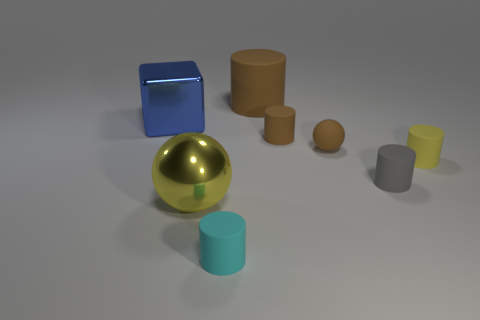Are there any gray things of the same size as the cyan matte cylinder?
Your answer should be compact. Yes. There is a blue thing left of the cyan cylinder; does it have the same shape as the gray object?
Keep it short and to the point. No. Does the tiny yellow rubber thing have the same shape as the blue shiny object?
Give a very brief answer. No. Is there another big green object of the same shape as the large rubber object?
Make the answer very short. No. There is a big object on the right side of the small cylinder in front of the large yellow object; what shape is it?
Offer a very short reply. Cylinder. The matte thing that is behind the large shiny cube is what color?
Ensure brevity in your answer.  Brown. What is the size of the cyan cylinder that is the same material as the tiny gray object?
Provide a succinct answer. Small. There is a gray rubber thing that is the same shape as the yellow rubber thing; what is its size?
Give a very brief answer. Small. Is there a gray rubber object?
Offer a very short reply. Yes. What number of objects are things to the left of the rubber sphere or rubber objects?
Make the answer very short. 8. 